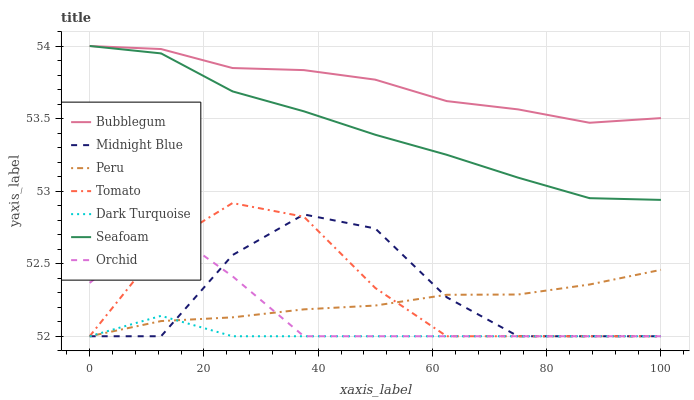Does Dark Turquoise have the minimum area under the curve?
Answer yes or no. Yes. Does Bubblegum have the maximum area under the curve?
Answer yes or no. Yes. Does Midnight Blue have the minimum area under the curve?
Answer yes or no. No. Does Midnight Blue have the maximum area under the curve?
Answer yes or no. No. Is Peru the smoothest?
Answer yes or no. Yes. Is Midnight Blue the roughest?
Answer yes or no. Yes. Is Dark Turquoise the smoothest?
Answer yes or no. No. Is Dark Turquoise the roughest?
Answer yes or no. No. Does Tomato have the lowest value?
Answer yes or no. Yes. Does Seafoam have the lowest value?
Answer yes or no. No. Does Bubblegum have the highest value?
Answer yes or no. Yes. Does Midnight Blue have the highest value?
Answer yes or no. No. Is Midnight Blue less than Seafoam?
Answer yes or no. Yes. Is Bubblegum greater than Peru?
Answer yes or no. Yes. Does Dark Turquoise intersect Tomato?
Answer yes or no. Yes. Is Dark Turquoise less than Tomato?
Answer yes or no. No. Is Dark Turquoise greater than Tomato?
Answer yes or no. No. Does Midnight Blue intersect Seafoam?
Answer yes or no. No. 